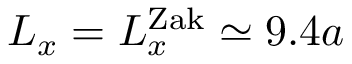Convert formula to latex. <formula><loc_0><loc_0><loc_500><loc_500>L _ { x } = L _ { x } ^ { Z a k } \simeq 9 . 4 a</formula> 